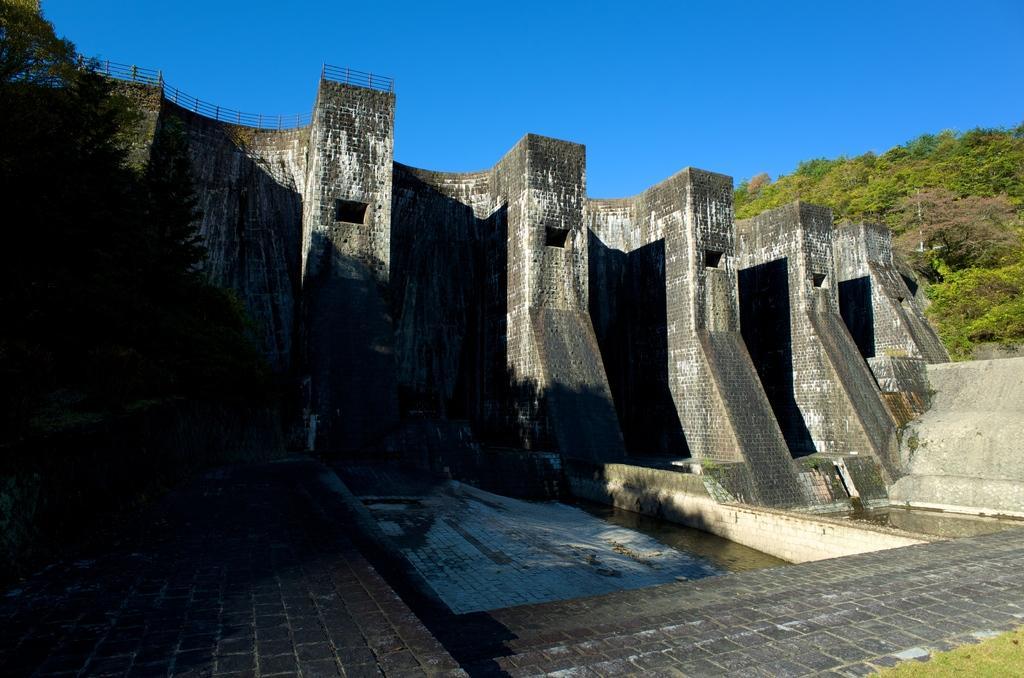In one or two sentences, can you explain what this image depicts? In this picture I can see a dam in front and in the background I see number of trees and the sky. 